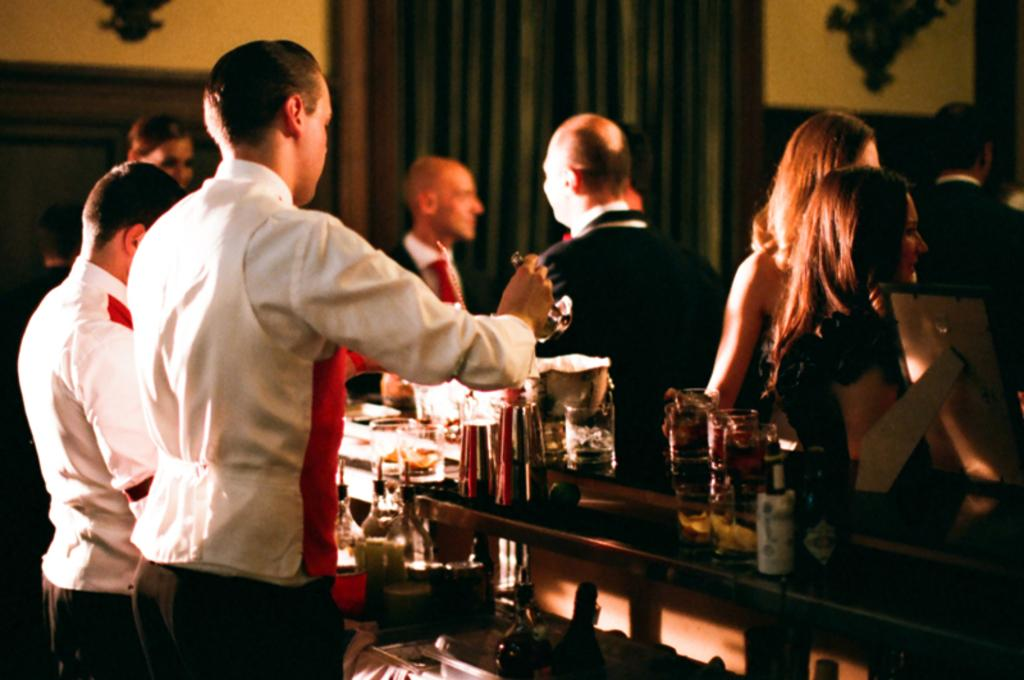What type of furniture is in the image? There is a bar counter in the image. What items can be seen on the bar counter? Bottles and glass are on the bar counter. Are there any people in the image? Yes, people are standing near the bar counter. What is visible in the background of the image? There is a wall in the background of the image. What type of plant is growing on the bar counter in the image? There is no plant growing on the bar counter in the image. What type of sound can be heard coming from the bar counter in the image? There is no sound coming from the bar counter in the image. 